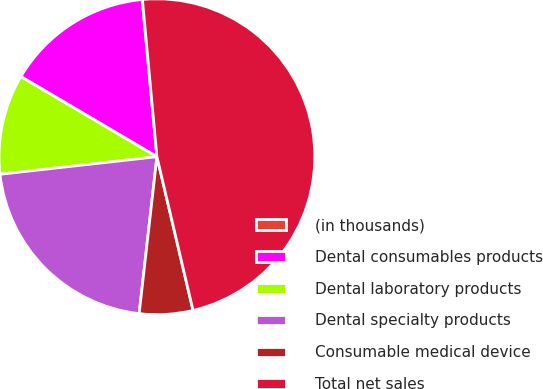<chart> <loc_0><loc_0><loc_500><loc_500><pie_chart><fcel>(in thousands)<fcel>Dental consumables products<fcel>Dental laboratory products<fcel>Dental specialty products<fcel>Consumable medical device<fcel>Total net sales<nl><fcel>0.03%<fcel>15.03%<fcel>10.25%<fcel>21.43%<fcel>5.47%<fcel>47.79%<nl></chart> 